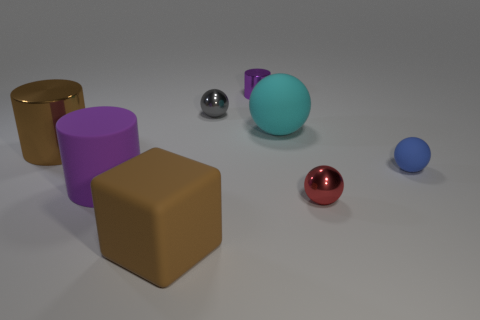What materials do the objects in the image seem to be made of? The objects appear to be of different materials. The cylinders and spheres exhibit a reflective quality suggesting they are metallic, while the cubes have a matte finish indicating a possible rubber or plastic composition. 